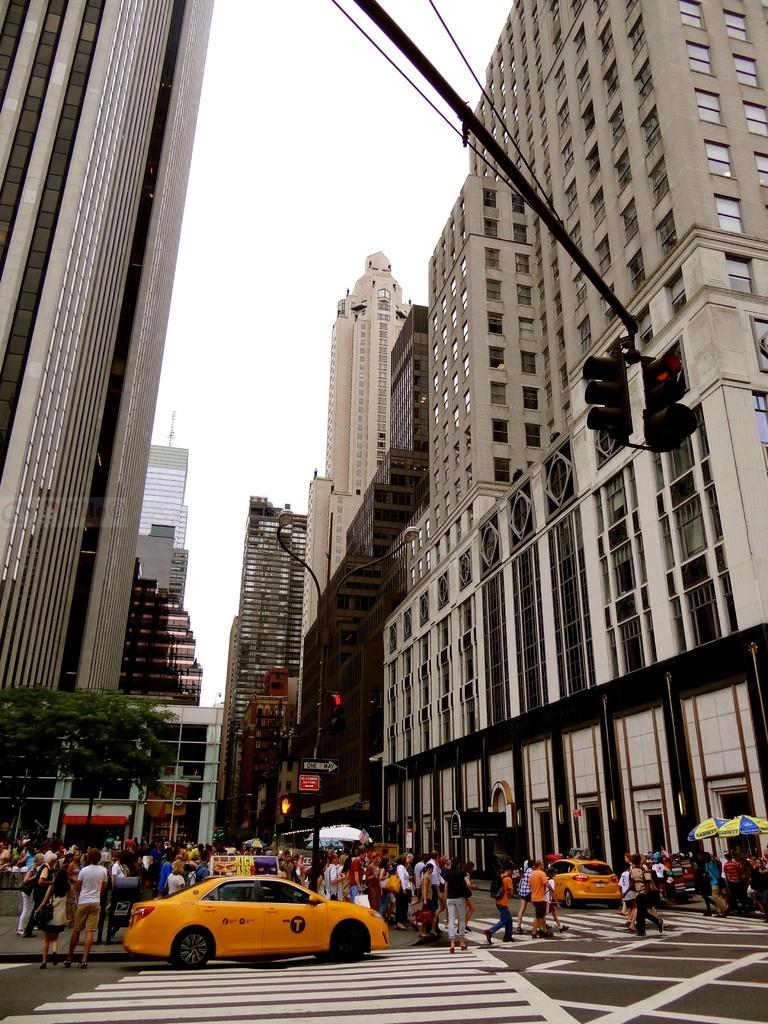What type of structures can be seen in the image? There are buildings in the image. What can be seen controlling the flow of traffic in the image? There are traffic signals in the image. What architectural feature is present in the buildings? There are windows in the image. Who or what can be seen in the image besides the buildings and traffic signals? There are people and cars visible in the image. What is visible in the background of the image? The sky is visible in the image. Can you see a smile on the branch of the rose in the image? There is no branch or rose present in the image. What type of smile is displayed by the people in the image? The provided facts do not mention any specific expressions or smiles of the people in the image. 